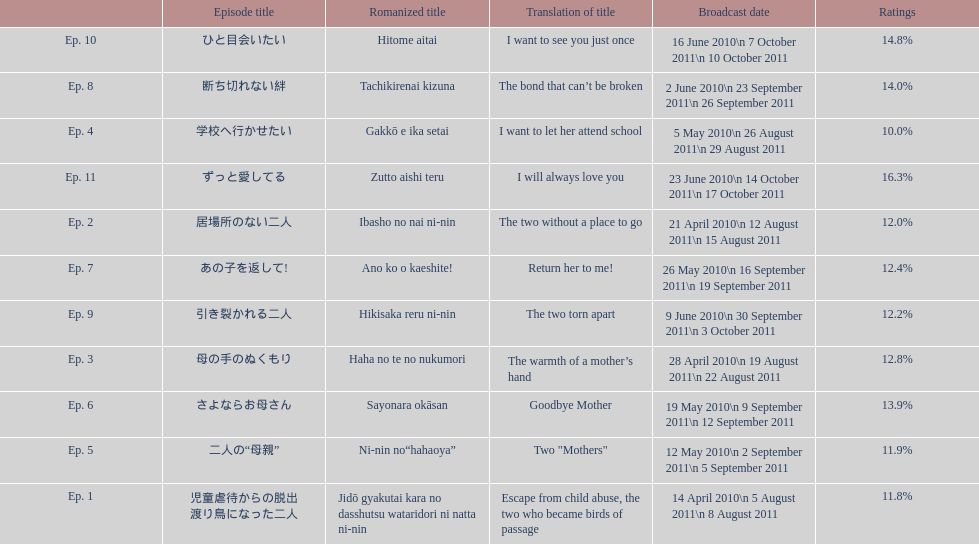Besides the 10th episode, which other episode possesses a 14% rating? Ep. 8. 